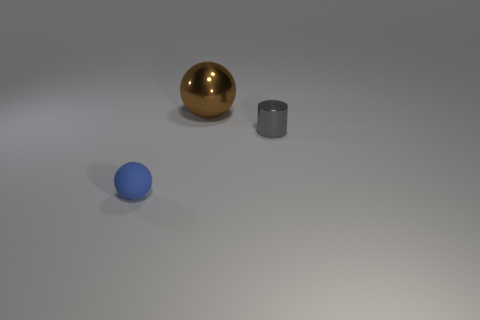Is there anything in the image that suggests scale or size? Without familiar objects or a clear frame of reference, it's difficult to determine the exact scale of the objects. However, given their simplistic geometrical shapes and the lack of any detailed textures or marks, they could be small-scale models placed on a tabletop setup for a photography or rendering project. 